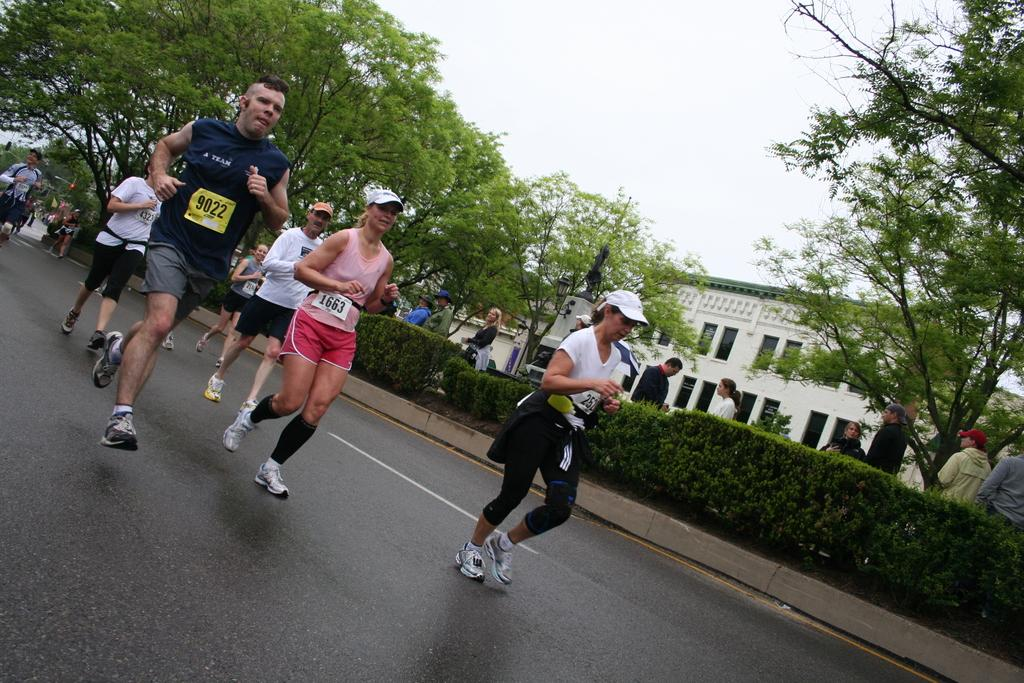What are the people in the image doing? The people in the image are running and walking on the road. What type of vegetation can be seen in the image? There are garden plants and trees in the image. What is used to control traffic in the image? There is a traffic signal in the image. What type of structure is present in the image? There is a building in the image. What is visible in the sky in the image? The sky is visible in the image. Can you see a cup being used by the insect in the image? There is no insect or cup present in the image. What is the temperature like in the image? The temperature or heat level cannot be determined from the image alone. 